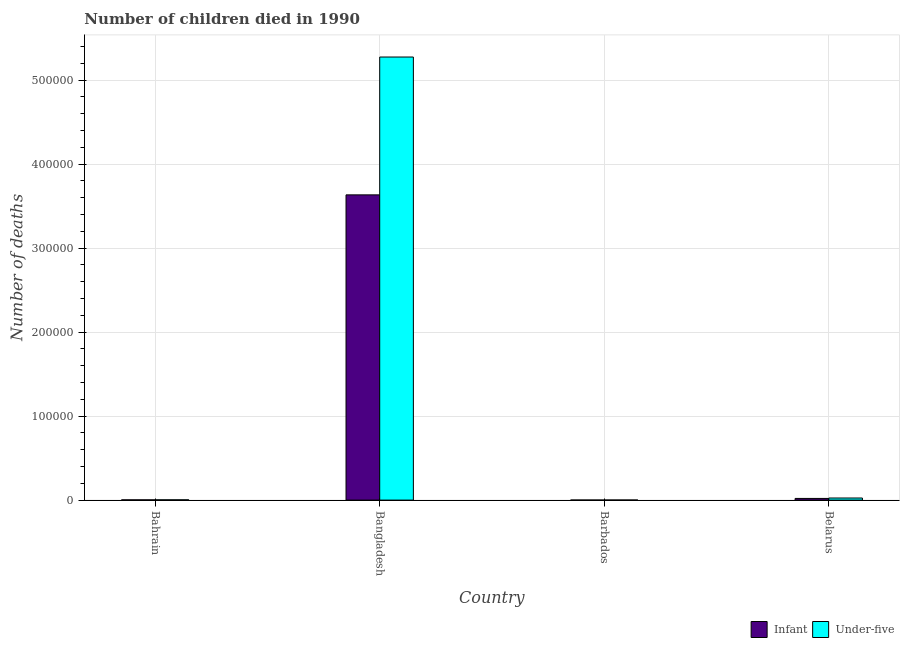Are the number of bars on each tick of the X-axis equal?
Keep it short and to the point. Yes. How many bars are there on the 4th tick from the left?
Offer a very short reply. 2. What is the label of the 4th group of bars from the left?
Your answer should be compact. Belarus. What is the number of infant deaths in Bangladesh?
Offer a very short reply. 3.63e+05. Across all countries, what is the maximum number of infant deaths?
Provide a succinct answer. 3.63e+05. Across all countries, what is the minimum number of infant deaths?
Your response must be concise. 64. In which country was the number of under-five deaths minimum?
Your answer should be compact. Barbados. What is the total number of infant deaths in the graph?
Give a very brief answer. 3.66e+05. What is the difference between the number of under-five deaths in Bangladesh and that in Belarus?
Provide a succinct answer. 5.25e+05. What is the difference between the number of infant deaths in Bangladesh and the number of under-five deaths in Belarus?
Keep it short and to the point. 3.61e+05. What is the average number of under-five deaths per country?
Offer a terse response. 1.33e+05. What is the difference between the number of infant deaths and number of under-five deaths in Bangladesh?
Offer a very short reply. -1.64e+05. What is the ratio of the number of infant deaths in Bahrain to that in Belarus?
Make the answer very short. 0.14. Is the difference between the number of under-five deaths in Bahrain and Belarus greater than the difference between the number of infant deaths in Bahrain and Belarus?
Ensure brevity in your answer.  No. What is the difference between the highest and the second highest number of infant deaths?
Your response must be concise. 3.61e+05. What is the difference between the highest and the lowest number of infant deaths?
Ensure brevity in your answer.  3.63e+05. In how many countries, is the number of under-five deaths greater than the average number of under-five deaths taken over all countries?
Ensure brevity in your answer.  1. Is the sum of the number of infant deaths in Bangladesh and Belarus greater than the maximum number of under-five deaths across all countries?
Offer a very short reply. No. What does the 2nd bar from the left in Barbados represents?
Your answer should be compact. Under-five. What does the 2nd bar from the right in Bangladesh represents?
Your answer should be compact. Infant. How many countries are there in the graph?
Provide a short and direct response. 4. Does the graph contain grids?
Offer a terse response. Yes. Where does the legend appear in the graph?
Ensure brevity in your answer.  Bottom right. How many legend labels are there?
Offer a terse response. 2. What is the title of the graph?
Provide a short and direct response. Number of children died in 1990. Does "Domestic liabilities" appear as one of the legend labels in the graph?
Your answer should be very brief. No. What is the label or title of the Y-axis?
Keep it short and to the point. Number of deaths. What is the Number of deaths in Infant in Bahrain?
Offer a terse response. 284. What is the Number of deaths in Under-five in Bahrain?
Your response must be concise. 331. What is the Number of deaths in Infant in Bangladesh?
Your response must be concise. 3.63e+05. What is the Number of deaths in Under-five in Bangladesh?
Offer a terse response. 5.28e+05. What is the Number of deaths in Infant in Barbados?
Ensure brevity in your answer.  64. What is the Number of deaths in Under-five in Barbados?
Your response must be concise. 72. What is the Number of deaths of Infant in Belarus?
Give a very brief answer. 1991. What is the Number of deaths of Under-five in Belarus?
Your answer should be very brief. 2495. Across all countries, what is the maximum Number of deaths of Infant?
Make the answer very short. 3.63e+05. Across all countries, what is the maximum Number of deaths of Under-five?
Give a very brief answer. 5.28e+05. Across all countries, what is the minimum Number of deaths of Infant?
Provide a succinct answer. 64. Across all countries, what is the minimum Number of deaths of Under-five?
Your answer should be compact. 72. What is the total Number of deaths of Infant in the graph?
Your answer should be very brief. 3.66e+05. What is the total Number of deaths of Under-five in the graph?
Ensure brevity in your answer.  5.30e+05. What is the difference between the Number of deaths of Infant in Bahrain and that in Bangladesh?
Your response must be concise. -3.63e+05. What is the difference between the Number of deaths in Under-five in Bahrain and that in Bangladesh?
Keep it short and to the point. -5.27e+05. What is the difference between the Number of deaths in Infant in Bahrain and that in Barbados?
Provide a short and direct response. 220. What is the difference between the Number of deaths of Under-five in Bahrain and that in Barbados?
Your answer should be compact. 259. What is the difference between the Number of deaths in Infant in Bahrain and that in Belarus?
Provide a short and direct response. -1707. What is the difference between the Number of deaths in Under-five in Bahrain and that in Belarus?
Offer a very short reply. -2164. What is the difference between the Number of deaths of Infant in Bangladesh and that in Barbados?
Ensure brevity in your answer.  3.63e+05. What is the difference between the Number of deaths in Under-five in Bangladesh and that in Barbados?
Give a very brief answer. 5.28e+05. What is the difference between the Number of deaths of Infant in Bangladesh and that in Belarus?
Make the answer very short. 3.61e+05. What is the difference between the Number of deaths in Under-five in Bangladesh and that in Belarus?
Offer a terse response. 5.25e+05. What is the difference between the Number of deaths of Infant in Barbados and that in Belarus?
Provide a succinct answer. -1927. What is the difference between the Number of deaths in Under-five in Barbados and that in Belarus?
Offer a terse response. -2423. What is the difference between the Number of deaths of Infant in Bahrain and the Number of deaths of Under-five in Bangladesh?
Make the answer very short. -5.27e+05. What is the difference between the Number of deaths in Infant in Bahrain and the Number of deaths in Under-five in Barbados?
Offer a very short reply. 212. What is the difference between the Number of deaths of Infant in Bahrain and the Number of deaths of Under-five in Belarus?
Provide a short and direct response. -2211. What is the difference between the Number of deaths in Infant in Bangladesh and the Number of deaths in Under-five in Barbados?
Your answer should be compact. 3.63e+05. What is the difference between the Number of deaths in Infant in Bangladesh and the Number of deaths in Under-five in Belarus?
Keep it short and to the point. 3.61e+05. What is the difference between the Number of deaths in Infant in Barbados and the Number of deaths in Under-five in Belarus?
Ensure brevity in your answer.  -2431. What is the average Number of deaths in Infant per country?
Your answer should be very brief. 9.15e+04. What is the average Number of deaths in Under-five per country?
Your response must be concise. 1.33e+05. What is the difference between the Number of deaths in Infant and Number of deaths in Under-five in Bahrain?
Keep it short and to the point. -47. What is the difference between the Number of deaths in Infant and Number of deaths in Under-five in Bangladesh?
Provide a succinct answer. -1.64e+05. What is the difference between the Number of deaths in Infant and Number of deaths in Under-five in Belarus?
Provide a succinct answer. -504. What is the ratio of the Number of deaths in Infant in Bahrain to that in Bangladesh?
Make the answer very short. 0. What is the ratio of the Number of deaths in Under-five in Bahrain to that in Bangladesh?
Ensure brevity in your answer.  0. What is the ratio of the Number of deaths in Infant in Bahrain to that in Barbados?
Ensure brevity in your answer.  4.44. What is the ratio of the Number of deaths in Under-five in Bahrain to that in Barbados?
Make the answer very short. 4.6. What is the ratio of the Number of deaths of Infant in Bahrain to that in Belarus?
Offer a terse response. 0.14. What is the ratio of the Number of deaths of Under-five in Bahrain to that in Belarus?
Make the answer very short. 0.13. What is the ratio of the Number of deaths in Infant in Bangladesh to that in Barbados?
Give a very brief answer. 5679.11. What is the ratio of the Number of deaths in Under-five in Bangladesh to that in Barbados?
Offer a very short reply. 7327.6. What is the ratio of the Number of deaths in Infant in Bangladesh to that in Belarus?
Ensure brevity in your answer.  182.55. What is the ratio of the Number of deaths in Under-five in Bangladesh to that in Belarus?
Ensure brevity in your answer.  211.46. What is the ratio of the Number of deaths in Infant in Barbados to that in Belarus?
Your answer should be very brief. 0.03. What is the ratio of the Number of deaths in Under-five in Barbados to that in Belarus?
Ensure brevity in your answer.  0.03. What is the difference between the highest and the second highest Number of deaths in Infant?
Provide a short and direct response. 3.61e+05. What is the difference between the highest and the second highest Number of deaths in Under-five?
Ensure brevity in your answer.  5.25e+05. What is the difference between the highest and the lowest Number of deaths in Infant?
Your response must be concise. 3.63e+05. What is the difference between the highest and the lowest Number of deaths of Under-five?
Your answer should be compact. 5.28e+05. 